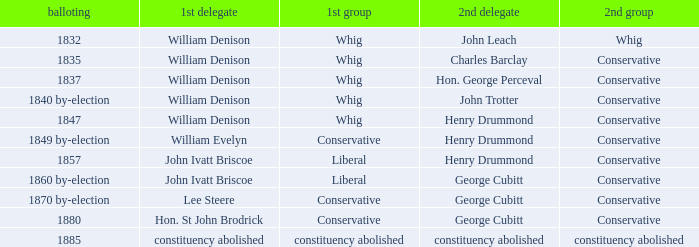Can you give me this table as a dict? {'header': ['balloting', '1st delegate', '1st group', '2nd delegate', '2nd group'], 'rows': [['1832', 'William Denison', 'Whig', 'John Leach', 'Whig'], ['1835', 'William Denison', 'Whig', 'Charles Barclay', 'Conservative'], ['1837', 'William Denison', 'Whig', 'Hon. George Perceval', 'Conservative'], ['1840 by-election', 'William Denison', 'Whig', 'John Trotter', 'Conservative'], ['1847', 'William Denison', 'Whig', 'Henry Drummond', 'Conservative'], ['1849 by-election', 'William Evelyn', 'Conservative', 'Henry Drummond', 'Conservative'], ['1857', 'John Ivatt Briscoe', 'Liberal', 'Henry Drummond', 'Conservative'], ['1860 by-election', 'John Ivatt Briscoe', 'Liberal', 'George Cubitt', 'Conservative'], ['1870 by-election', 'Lee Steere', 'Conservative', 'George Cubitt', 'Conservative'], ['1880', 'Hon. St John Brodrick', 'Conservative', 'George Cubitt', 'Conservative'], ['1885', 'constituency abolished', 'constituency abolished', 'constituency abolished', 'constituency abolished']]} Which party's 1st member is John Ivatt Briscoe in an election in 1857? Liberal. 